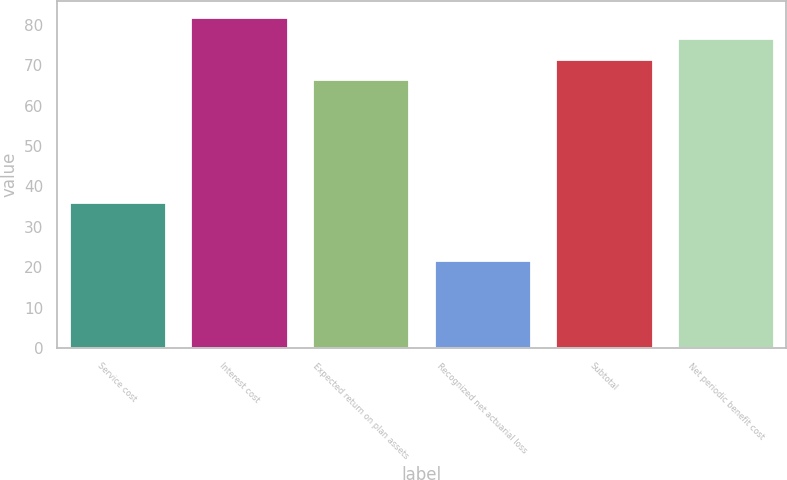Convert chart. <chart><loc_0><loc_0><loc_500><loc_500><bar_chart><fcel>Service cost<fcel>Interest cost<fcel>Expected return on plan assets<fcel>Recognized net actuarial loss<fcel>Subtotal<fcel>Net periodic benefit cost<nl><fcel>36.2<fcel>81.9<fcel>66.6<fcel>21.7<fcel>71.7<fcel>76.8<nl></chart> 